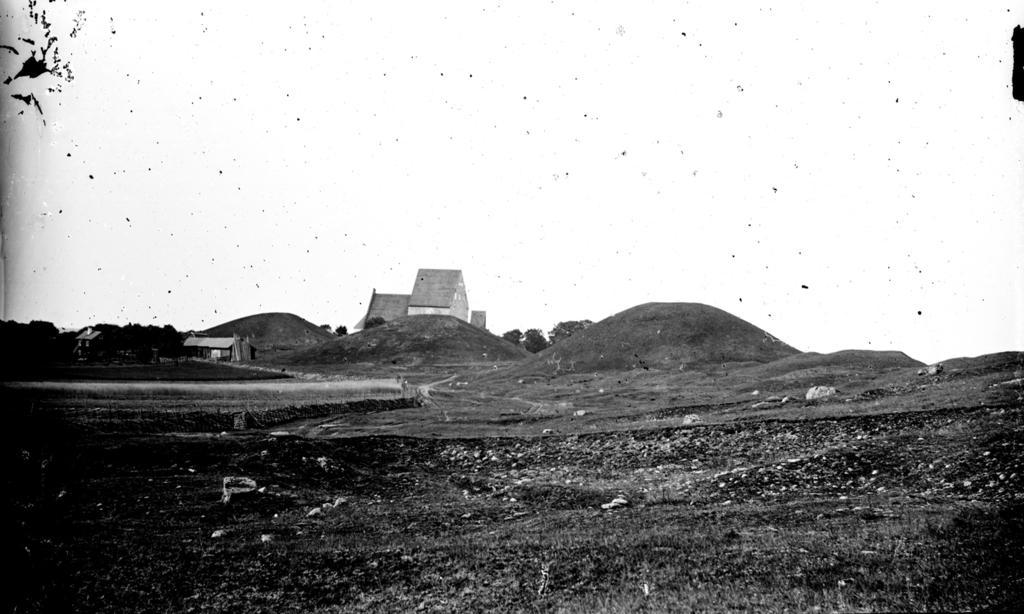In one or two sentences, can you explain what this image depicts? This is a black and white image. In this image we can see hills, trees, shelters and other objects. At the top of the image there is the sky. At the bottom of the image there is the ground. 